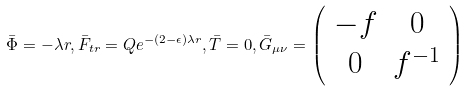<formula> <loc_0><loc_0><loc_500><loc_500>\bar { \Phi } = - \lambda r , \bar { F } _ { t r } = Q e ^ { - ( 2 - \epsilon ) \lambda r } , \bar { T } = 0 , \bar { G } _ { \mu \nu } = \left ( \begin{array} { c c } { - f } & { 0 } \\ { 0 } & { { f ^ { - 1 } } } \end{array} \right )</formula> 